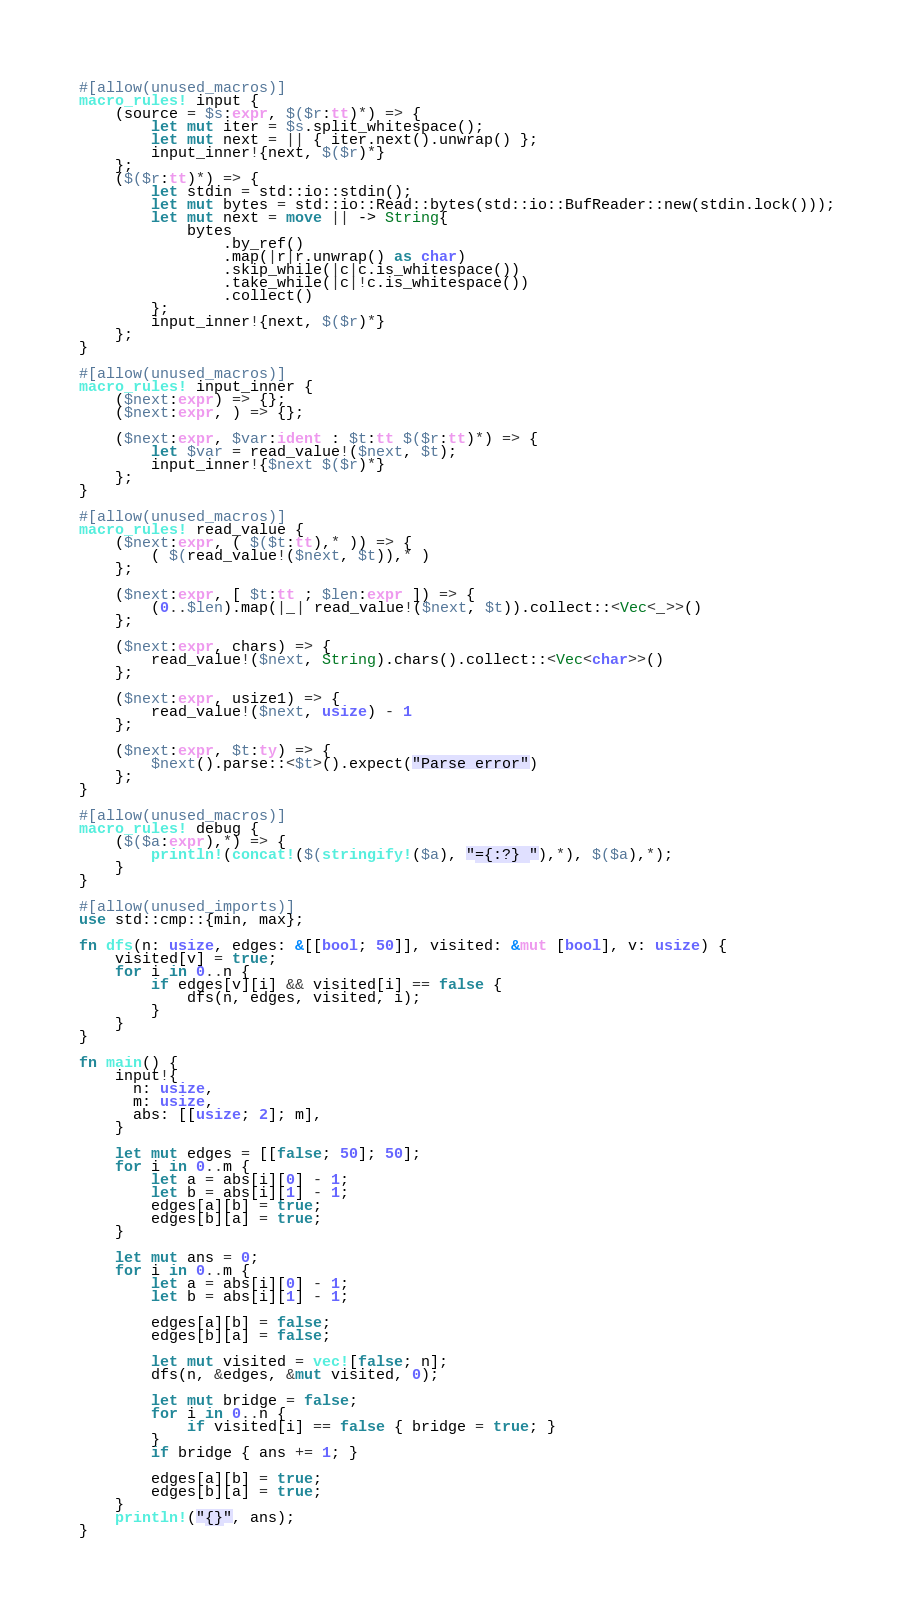Convert code to text. <code><loc_0><loc_0><loc_500><loc_500><_Rust_>#[allow(unused_macros)]
macro_rules! input {
    (source = $s:expr, $($r:tt)*) => {
        let mut iter = $s.split_whitespace();
        let mut next = || { iter.next().unwrap() };
        input_inner!{next, $($r)*}
    };
    ($($r:tt)*) => {
        let stdin = std::io::stdin();
        let mut bytes = std::io::Read::bytes(std::io::BufReader::new(stdin.lock()));
        let mut next = move || -> String{
            bytes
                .by_ref()
                .map(|r|r.unwrap() as char)
                .skip_while(|c|c.is_whitespace())
                .take_while(|c|!c.is_whitespace())
                .collect()
        };
        input_inner!{next, $($r)*}
    };
}

#[allow(unused_macros)]
macro_rules! input_inner {
    ($next:expr) => {};
    ($next:expr, ) => {};

    ($next:expr, $var:ident : $t:tt $($r:tt)*) => {
        let $var = read_value!($next, $t);
        input_inner!{$next $($r)*}
    };
}

#[allow(unused_macros)]
macro_rules! read_value {
    ($next:expr, ( $($t:tt),* )) => {
        ( $(read_value!($next, $t)),* )
    };

    ($next:expr, [ $t:tt ; $len:expr ]) => {
        (0..$len).map(|_| read_value!($next, $t)).collect::<Vec<_>>()
    };

    ($next:expr, chars) => {
        read_value!($next, String).chars().collect::<Vec<char>>()
    };

    ($next:expr, usize1) => {
        read_value!($next, usize) - 1
    };

    ($next:expr, $t:ty) => {
        $next().parse::<$t>().expect("Parse error")
    };
}

#[allow(unused_macros)]
macro_rules! debug {
    ($($a:expr),*) => {
        println!(concat!($(stringify!($a), "={:?} "),*), $($a),*);
    }
}

#[allow(unused_imports)]
use std::cmp::{min, max};

fn dfs(n: usize, edges: &[[bool; 50]], visited: &mut [bool], v: usize) {
    visited[v] = true;
    for i in 0..n {
        if edges[v][i] && visited[i] == false {
            dfs(n, edges, visited, i);
        }
    }
}

fn main() {
    input!{
      n: usize,
      m: usize,
      abs: [[usize; 2]; m],
    }

    let mut edges = [[false; 50]; 50];
    for i in 0..m {
        let a = abs[i][0] - 1;
        let b = abs[i][1] - 1;
        edges[a][b] = true;
        edges[b][a] = true;
    }

    let mut ans = 0;
    for i in 0..m {
        let a = abs[i][0] - 1;
        let b = abs[i][1] - 1;

        edges[a][b] = false;
        edges[b][a] = false;

        let mut visited = vec![false; n];
        dfs(n, &edges, &mut visited, 0);

        let mut bridge = false;
        for i in 0..n {
            if visited[i] == false { bridge = true; }
        }
        if bridge { ans += 1; }

        edges[a][b] = true;
        edges[b][a] = true;
    }
    println!("{}", ans);
}
</code> 